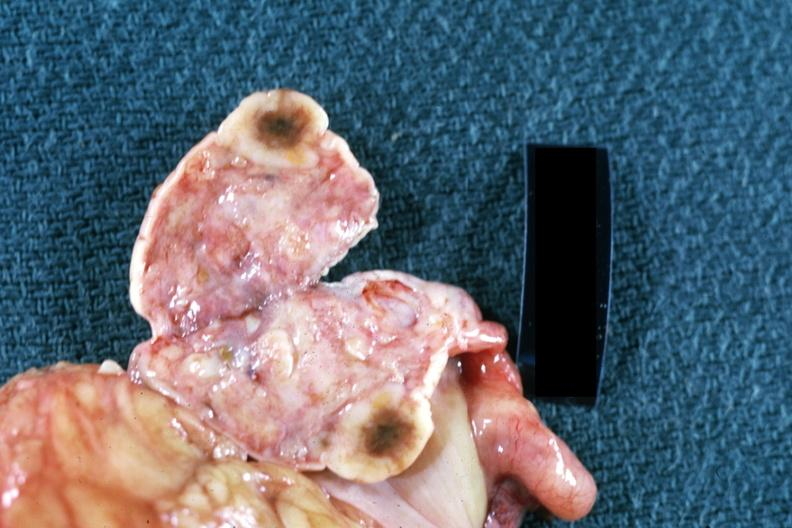s hemorrhagic corpus luteum present?
Answer the question using a single word or phrase. No 